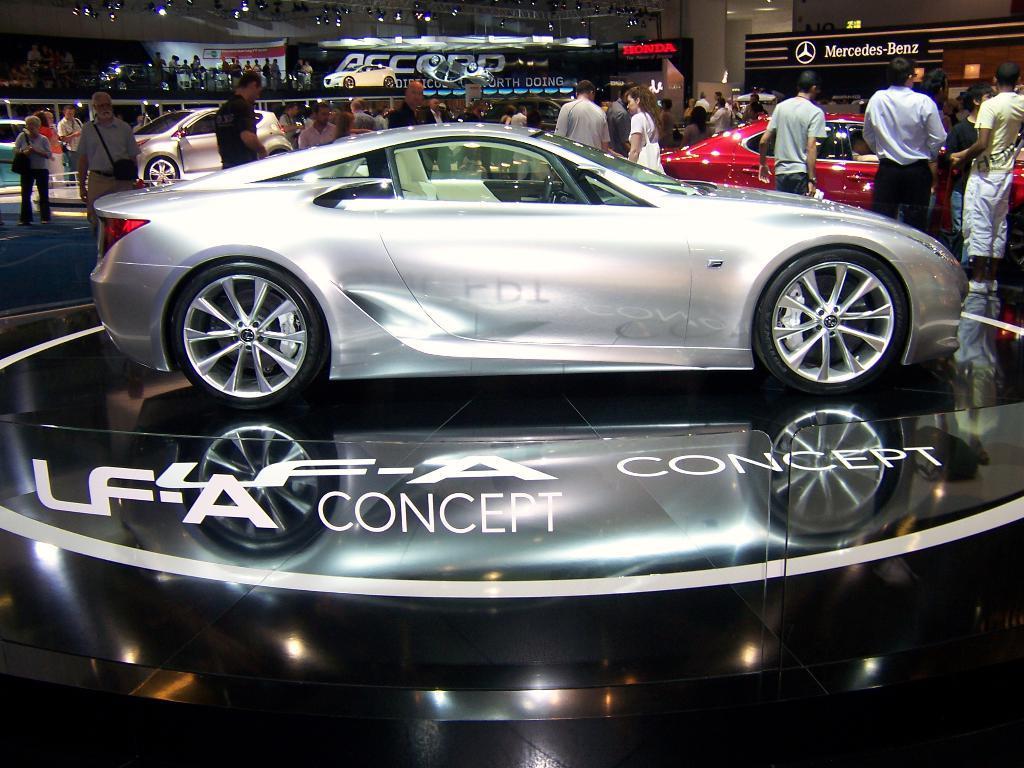How would you summarize this image in a sentence or two? In this picture I can see vehicles, there are group of people standing, there are lights, lighting truss and there are boards. 